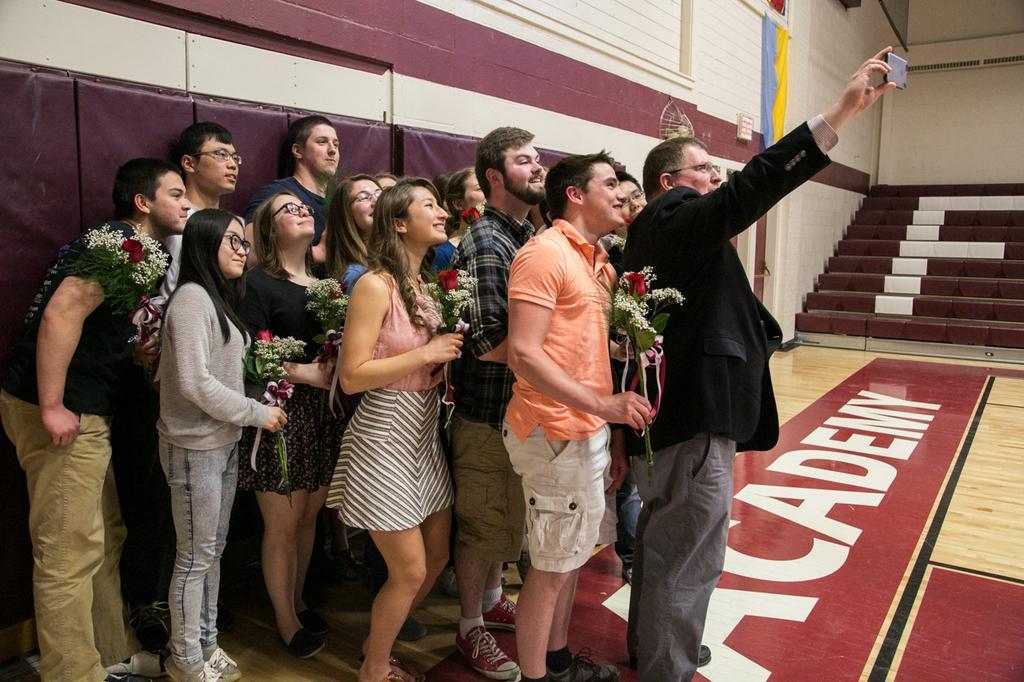Could you give a brief overview of what you see in this image? There is group of persons some of them are holding flower buckeyes, and a person who is in black color coat and is holding a mobile and capturing a photo of them, on the floor of a building, which is having steps and walls. 